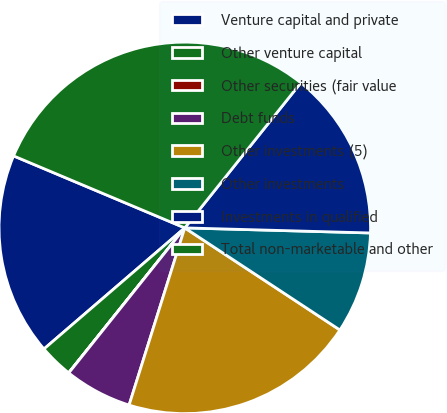Convert chart. <chart><loc_0><loc_0><loc_500><loc_500><pie_chart><fcel>Venture capital and private<fcel>Other venture capital<fcel>Other securities (fair value<fcel>Debt funds<fcel>Other investments (5)<fcel>Other investments<fcel>Investments in qualified<fcel>Total non-marketable and other<nl><fcel>17.64%<fcel>2.95%<fcel>0.01%<fcel>5.89%<fcel>20.58%<fcel>8.83%<fcel>14.7%<fcel>29.4%<nl></chart> 